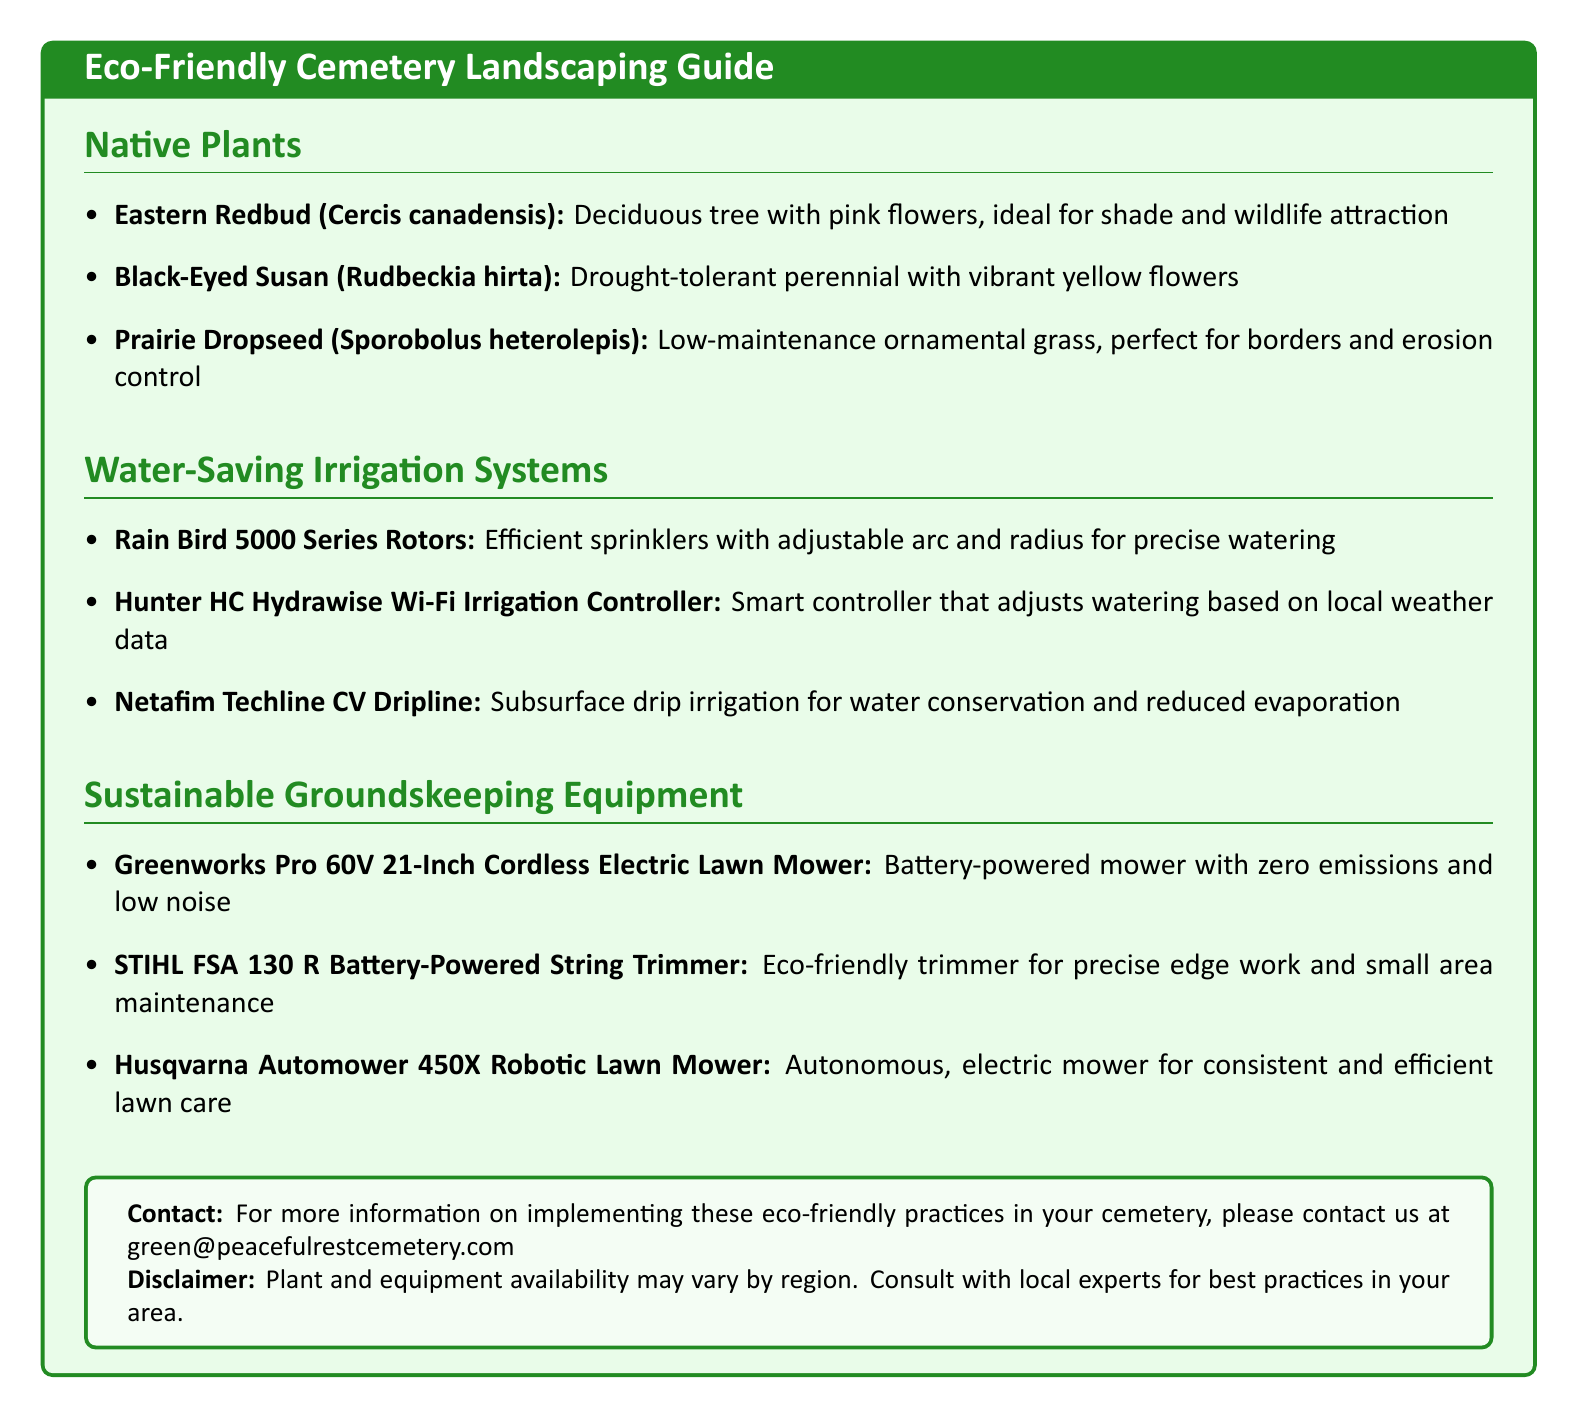What is one benefit of the Eastern Redbud? The Eastern Redbud is ideal for shade and wildlife attraction, highlighting its ecological benefits.
Answer: Shade and wildlife attraction What type of irrigation system does the Hunter HC Hydrawise use? The Hunter HC Hydrawise adjusts watering based on local weather data, showing its smart technology feature.
Answer: Smart controller What is one feature of the Greenworks Pro 60V mower? The Greenworks Pro 60V mower is battery-powered, emphasizing its eco-friendly nature with zero emissions.
Answer: Zero emissions How many native plants are listed in the guide? The document lists three native plants under the Native Plants section, providing options for eco-friendly landscaping.
Answer: Three What does the Netafim Techline CV Dripline conserve? The Netafim Techline CV Dripline is specifically designed for water conservation, making it an efficient choice for irrigation.
Answer: Water Which equipment is described as robotic? The Husqvarna Automower 450X is the only equipment described as robotic, indicating its innovative approach to groundskeeping.
Answer: Husqvarna Automower 450X What color scheme is used in the document's title? The document employs a color scheme of light green and forest green for the title, reinforcing its eco-friendly theme.
Answer: Light green and forest green What is the contact email for more information? The document provides a specific contact email for inquiries, demonstrating accessibility for further questions about eco-friendly practices.
Answer: green@peacefulrestcemetery.com What is a characteristic of the Prairie Dropseed? The Prairie Dropseed is characterized as a low-maintenance grass, indicating its suitability for sustainable landscaping practices.
Answer: Low-maintenance 